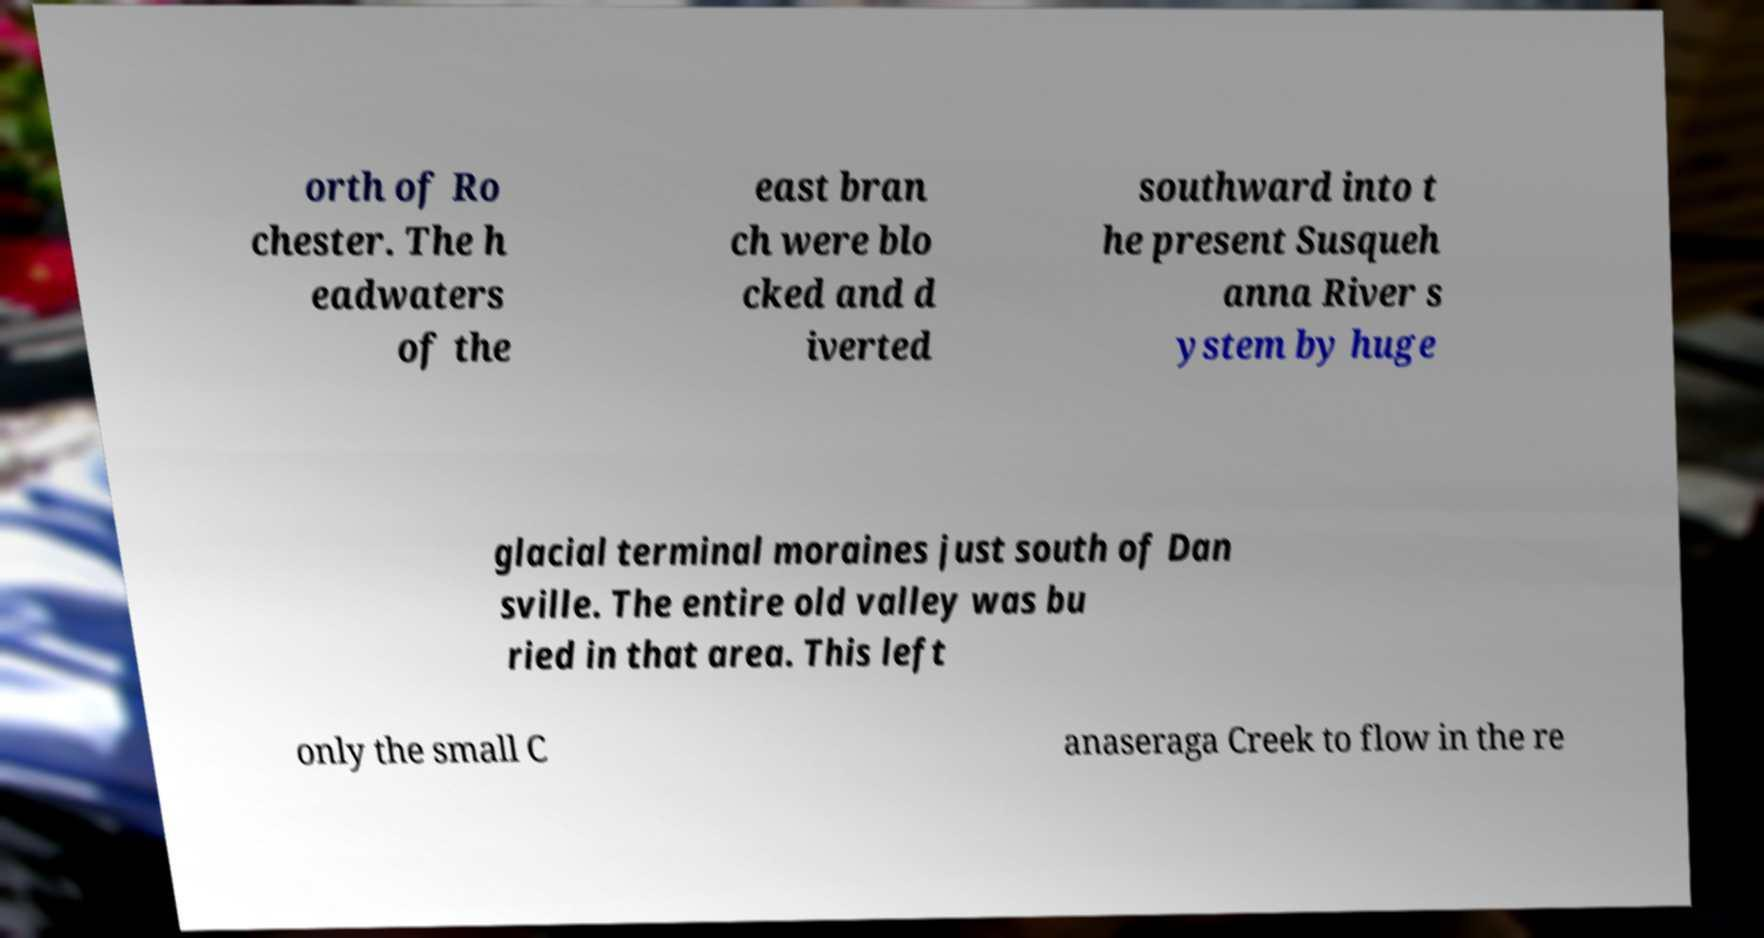Could you extract and type out the text from this image? orth of Ro chester. The h eadwaters of the east bran ch were blo cked and d iverted southward into t he present Susqueh anna River s ystem by huge glacial terminal moraines just south of Dan sville. The entire old valley was bu ried in that area. This left only the small C anaseraga Creek to flow in the re 